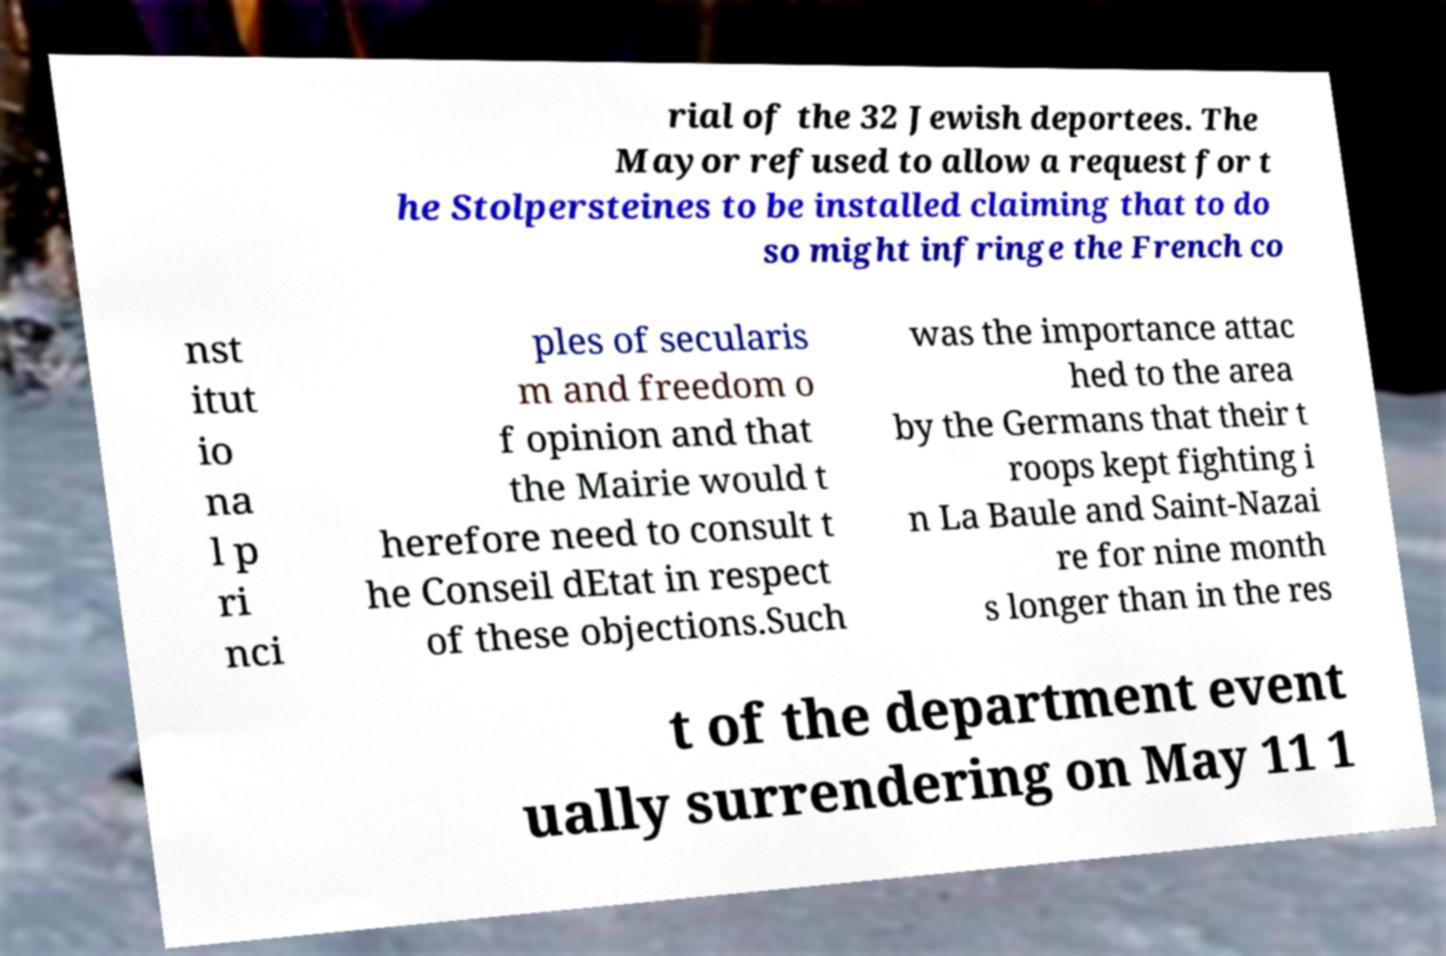Please identify and transcribe the text found in this image. rial of the 32 Jewish deportees. The Mayor refused to allow a request for t he Stolpersteines to be installed claiming that to do so might infringe the French co nst itut io na l p ri nci ples of secularis m and freedom o f opinion and that the Mairie would t herefore need to consult t he Conseil dEtat in respect of these objections.Such was the importance attac hed to the area by the Germans that their t roops kept fighting i n La Baule and Saint-Nazai re for nine month s longer than in the res t of the department event ually surrendering on May 11 1 